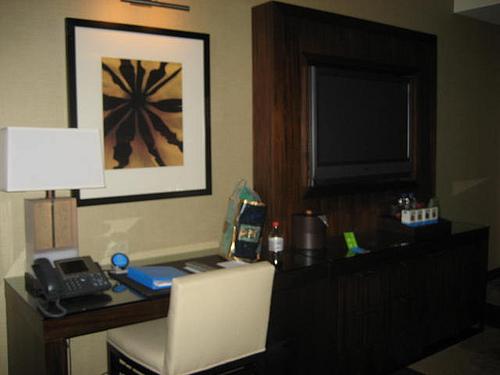What color is the chair?
Concise answer only. White. What color is the mantle?
Short answer required. Brown. Is this an old TV?
Be succinct. No. What is in the box next to the stand?
Give a very brief answer. Water. What color is the binder?
Write a very short answer. Blue. Is it a real wall in the mirror?
Concise answer only. No. Whose portrait can be seen on the glass?
Concise answer only. Flower. Is there a picture of a person in the picture frame?
Keep it brief. No. How many lamps are in the room?
Keep it brief. 1. What room is this?
Give a very brief answer. Hotel room. Is this a colorful room?
Short answer required. No. How many doors are there?
Quick response, please. 0. Is there a television in the photo?
Be succinct. Yes. What is the appliance on the counter?
Short answer required. Phone. What is in the picture?
Be succinct. Desk by wall. What type of art is represented in the picture on the wall?
Concise answer only. Abstract. How bright is this house?
Be succinct. Dim. Is anyone living in this home?
Answer briefly. Yes. 